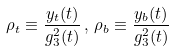Convert formula to latex. <formula><loc_0><loc_0><loc_500><loc_500>\rho _ { t } \equiv \frac { y _ { t } ( t ) } { g _ { 3 } ^ { 2 } ( t ) } \, , \, \rho _ { b } \equiv \frac { y _ { b } ( t ) } { g _ { 3 } ^ { 2 } ( t ) }</formula> 